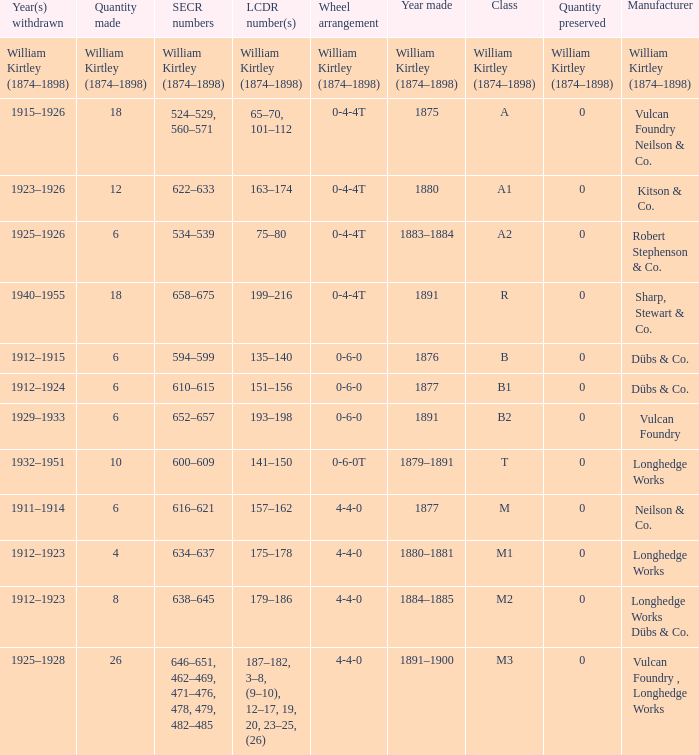Which class was made in 1880? A1. 